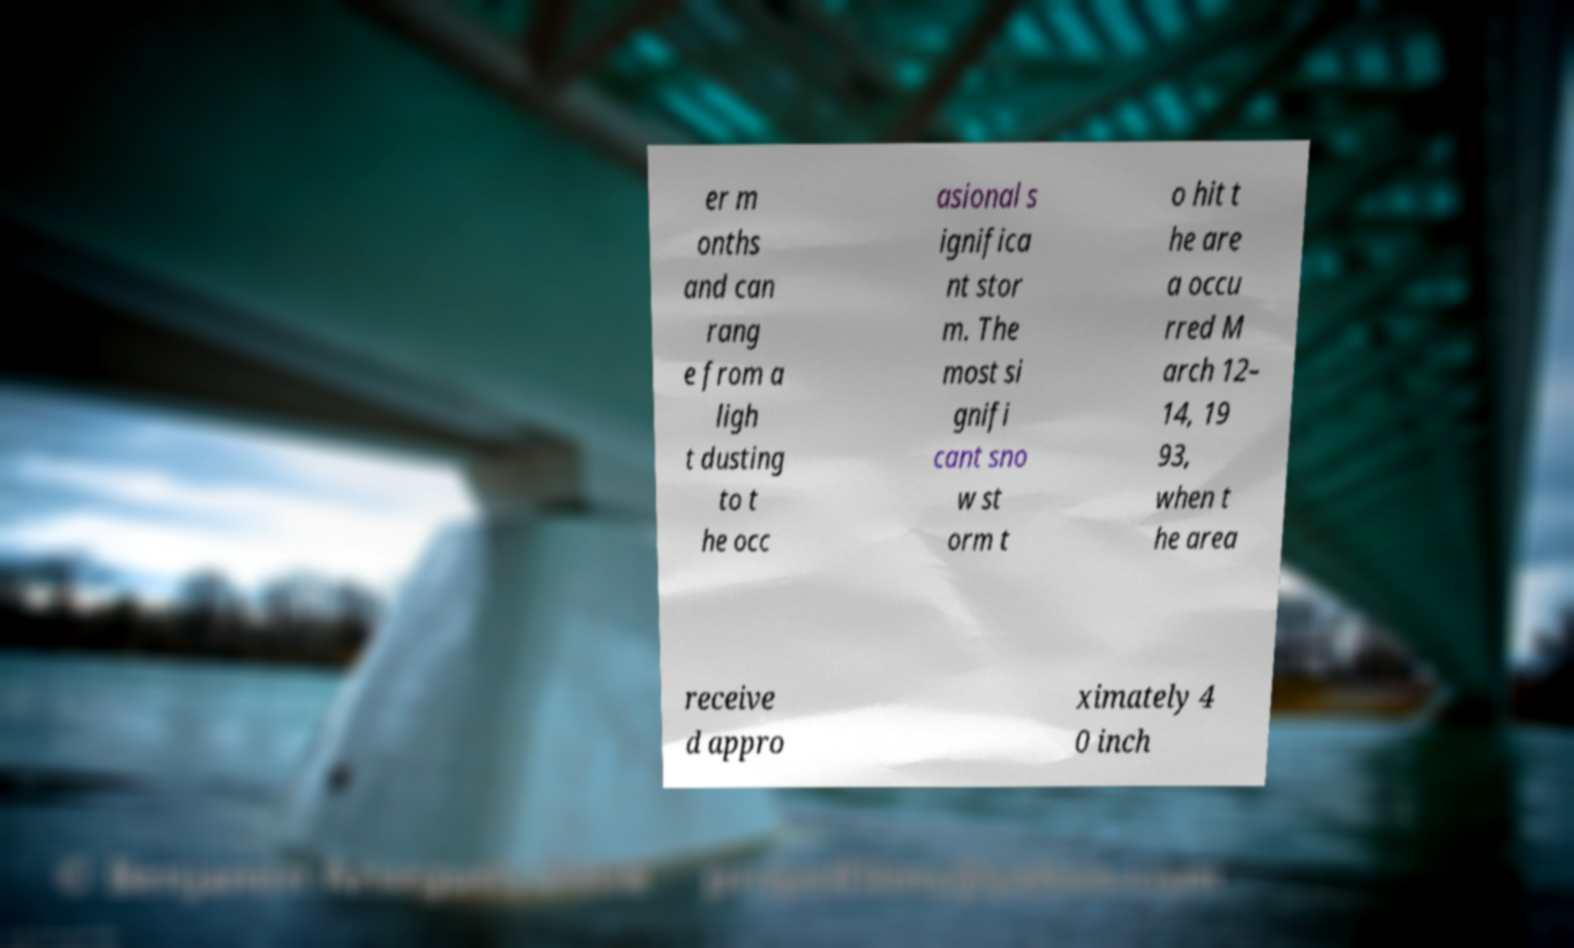Please identify and transcribe the text found in this image. er m onths and can rang e from a ligh t dusting to t he occ asional s ignifica nt stor m. The most si gnifi cant sno w st orm t o hit t he are a occu rred M arch 12– 14, 19 93, when t he area receive d appro ximately 4 0 inch 